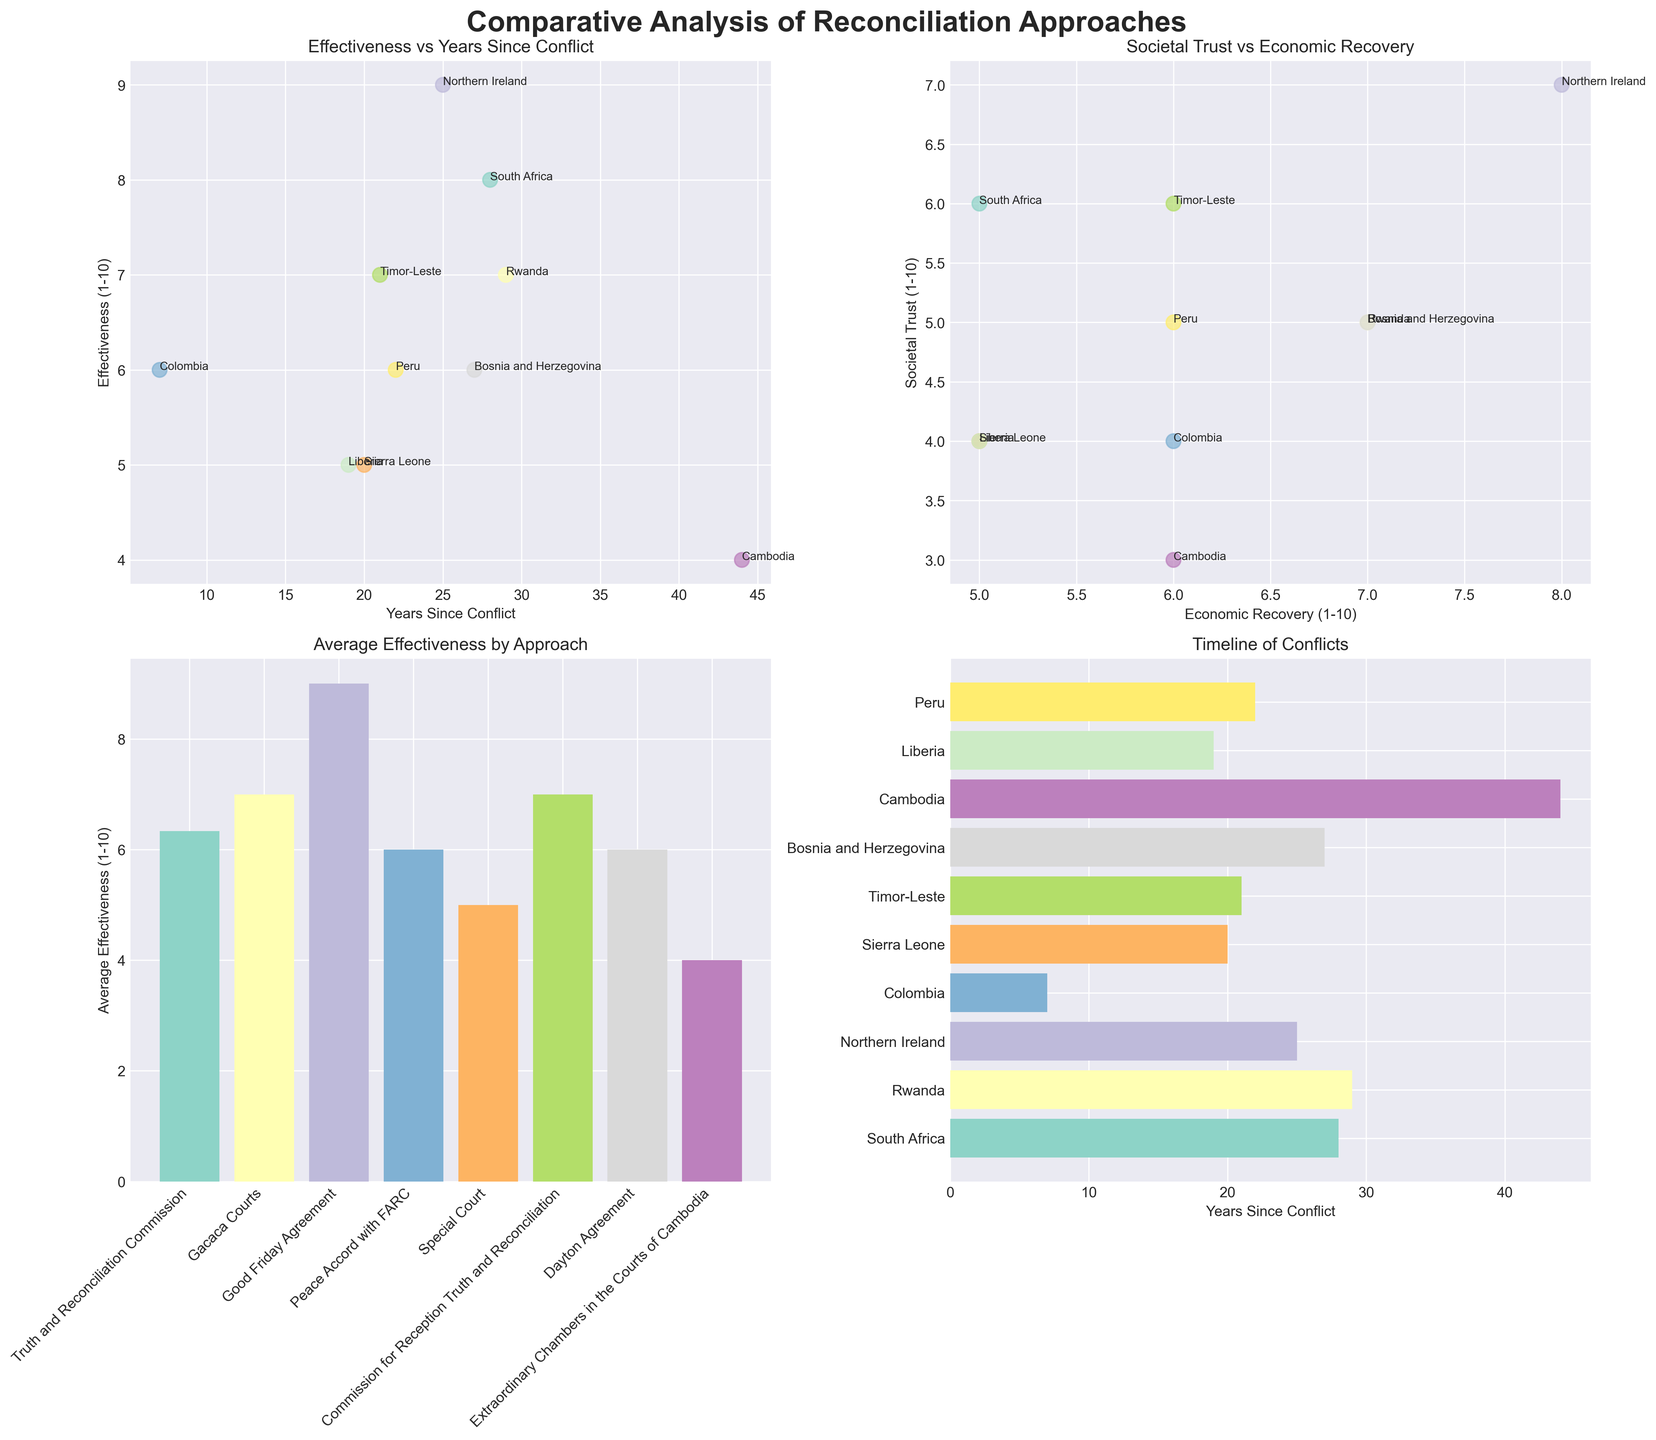What is the title of the figure? The title is placed at the top center of the figure and reads "Comparative Analysis of Reconciliation Approaches."
Answer: Comparative Analysis of Reconciliation Approaches Which country has the highest effectiveness in reconciliation approaches? In the subplot titled "Effectiveness vs Years Since Conflict," the data point with the highest effectiveness is labeled as Northern Ireland.
Answer: Northern Ireland What is the relationship between economic recovery and societal trust in post-conflict societies? By examining the "Societal Trust vs Economic Recovery" plot, we can see an overall positive trend, indicating that higher economic recovery often correlates with higher societal trust.
Answer: Positive correlation Which reconciliation approach has the widest range of effectiveness among countries? By looking at the "Average Effectiveness by Approach" plot, we can see that approaches like the Truth and Reconciliation Commission have a large spread among different countries (e.g., South Africa, Liberia, Peru).
Answer: Truth and Reconciliation Commission Is there any country that shows a high effectiveness but low societal trust? Checking the subplots for effectiveness and societal trust, Colombia has a relatively low societal trust score despite having a moderate effectiveness score.
Answer: Colombia How many years since conflict does the Good Friday Agreement in Northern Ireland have? "Timeline of Conflicts" plot shows that Northern Ireland has 25 years since the conflict ended.
Answer: 25 years What average effectiveness score does the Truth and Reconciliation Commission approach achieve? From the "Average Effectiveness by Approach" plot, we observe the Truth and Reconciliation Commission has an average effectiveness score around 6.3.
Answer: Around 6.3 Between South Africa and Rwanda, which country has a higher societal trust score? Referring to "Societal Trust vs Economic Recovery," Rwanda has a societal trust score of 5 while South Africa has a score of 6.
Answer: South Africa Which country shows the longest time since its conflict ended? The "Timeline of Conflicts" subplot shows that Cambodia has the longest time since the conflict ended, at 44 years.
Answer: Cambodia Does Sierra Leone have a higher economic recovery score than Liberia? Observing the "Societal Trust vs Economic Recovery" subplot, Sierra Leone has an economic recovery score of 5 while Liberia has a score of 5.
Answer: No, they are equal 